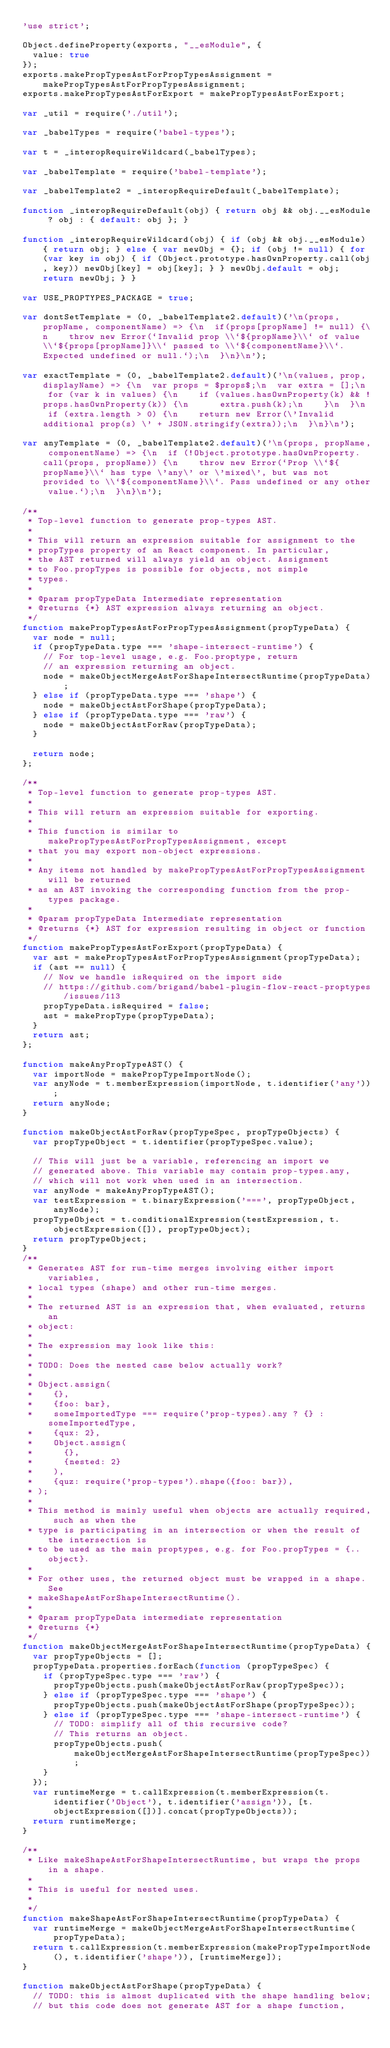<code> <loc_0><loc_0><loc_500><loc_500><_JavaScript_>'use strict';

Object.defineProperty(exports, "__esModule", {
  value: true
});
exports.makePropTypesAstForPropTypesAssignment = makePropTypesAstForPropTypesAssignment;
exports.makePropTypesAstForExport = makePropTypesAstForExport;

var _util = require('./util');

var _babelTypes = require('babel-types');

var t = _interopRequireWildcard(_babelTypes);

var _babelTemplate = require('babel-template');

var _babelTemplate2 = _interopRequireDefault(_babelTemplate);

function _interopRequireDefault(obj) { return obj && obj.__esModule ? obj : { default: obj }; }

function _interopRequireWildcard(obj) { if (obj && obj.__esModule) { return obj; } else { var newObj = {}; if (obj != null) { for (var key in obj) { if (Object.prototype.hasOwnProperty.call(obj, key)) newObj[key] = obj[key]; } } newObj.default = obj; return newObj; } }

var USE_PROPTYPES_PACKAGE = true;

var dontSetTemplate = (0, _babelTemplate2.default)('\n(props, propName, componentName) => {\n  if(props[propName] != null) {\n    throw new Error(`Invalid prop \\`${propName}\\` of value \\`${props[propName]}\\` passed to \\`${componentName}\\`. Expected undefined or null.`);\n  }\n}\n');

var exactTemplate = (0, _babelTemplate2.default)('\n(values, prop, displayName) => {\n  var props = $props$;\n  var extra = [];\n  for (var k in values) {\n    if (values.hasOwnProperty(k) && !props.hasOwnProperty(k)) {\n      extra.push(k);\n    }\n  }\n  if (extra.length > 0) {\n    return new Error(\'Invalid additional prop(s) \' + JSON.stringify(extra));\n  }\n}\n');

var anyTemplate = (0, _babelTemplate2.default)('\n(props, propName, componentName) => {\n  if (!Object.prototype.hasOwnProperty.call(props, propName)) {\n    throw new Error(`Prop \\`${propName}\\` has type \'any\' or \'mixed\', but was not provided to \\`${componentName}\\`. Pass undefined or any other value.`);\n  }\n}\n');

/**
 * Top-level function to generate prop-types AST.
 *
 * This will return an expression suitable for assignment to the
 * propTypes property of an React component. In particular,
 * the AST returned will always yield an object. Assignment
 * to Foo.propTypes is possible for objects, not simple
 * types.
 *
 * @param propTypeData Intermediate representation
 * @returns {*} AST expression always returning an object.
 */
function makePropTypesAstForPropTypesAssignment(propTypeData) {
  var node = null;
  if (propTypeData.type === 'shape-intersect-runtime') {
    // For top-level usage, e.g. Foo.proptype, return
    // an expression returning an object.
    node = makeObjectMergeAstForShapeIntersectRuntime(propTypeData);
  } else if (propTypeData.type === 'shape') {
    node = makeObjectAstForShape(propTypeData);
  } else if (propTypeData.type === 'raw') {
    node = makeObjectAstForRaw(propTypeData);
  }

  return node;
};

/**
 * Top-level function to generate prop-types AST.
 *
 * This will return an expression suitable for exporting.
 *
 * This function is similar to makePropTypesAstForPropTypesAssignment, except
 * that you may export non-object expressions.
 *
 * Any items not handled by makePropTypesAstForPropTypesAssignment will be returned
 * as an AST invoking the corresponding function from the prop-types package.
 *
 * @param propTypeData Intermediate representation
 * @returns {*} AST for expression resulting in object or function
 */
function makePropTypesAstForExport(propTypeData) {
  var ast = makePropTypesAstForPropTypesAssignment(propTypeData);
  if (ast == null) {
    // Now we handle isRequired on the import side
    // https://github.com/brigand/babel-plugin-flow-react-proptypes/issues/113
    propTypeData.isRequired = false;
    ast = makePropType(propTypeData);
  }
  return ast;
};

function makeAnyPropTypeAST() {
  var importNode = makePropTypeImportNode();
  var anyNode = t.memberExpression(importNode, t.identifier('any'));
  return anyNode;
}

function makeObjectAstForRaw(propTypeSpec, propTypeObjects) {
  var propTypeObject = t.identifier(propTypeSpec.value);

  // This will just be a variable, referencing an import we
  // generated above. This variable may contain prop-types.any,
  // which will not work when used in an intersection.
  var anyNode = makeAnyPropTypeAST();
  var testExpression = t.binaryExpression('===', propTypeObject, anyNode);
  propTypeObject = t.conditionalExpression(testExpression, t.objectExpression([]), propTypeObject);
  return propTypeObject;
}
/**
 * Generates AST for run-time merges involving either import variables,
 * local types (shape) and other run-time merges.
 *
 * The returned AST is an expression that, when evaluated, returns an
 * object:
 *
 * The expression may look like this:
 *
 * TODO: Does the nested case below actually work?
 *
 * Object.assign(
 *    {},
 *    {foo: bar},
 *    someImportedType === require('prop-types).any ? {} : someImportedType,
 *    {qux: 2},
 *    Object.assign(
 *      {},
 *      {nested: 2}
 *    ),
 *    {quz: require('prop-types').shape({foo: bar}),
 * );
 *
 * This method is mainly useful when objects are actually required, such as when the
 * type is participating in an intersection or when the result of the intersection is
 * to be used as the main proptypes, e.g. for Foo.propTypes = {..object}.
 *
 * For other uses, the returned object must be wrapped in a shape. See
 * makeShapeAstForShapeIntersectRuntime().
 *
 * @param propTypeData intermediate representation
 * @returns {*}
 */
function makeObjectMergeAstForShapeIntersectRuntime(propTypeData) {
  var propTypeObjects = [];
  propTypeData.properties.forEach(function (propTypeSpec) {
    if (propTypeSpec.type === 'raw') {
      propTypeObjects.push(makeObjectAstForRaw(propTypeSpec));
    } else if (propTypeSpec.type === 'shape') {
      propTypeObjects.push(makeObjectAstForShape(propTypeSpec));
    } else if (propTypeSpec.type === 'shape-intersect-runtime') {
      // TODO: simplify all of this recursive code?
      // This returns an object.
      propTypeObjects.push(makeObjectMergeAstForShapeIntersectRuntime(propTypeSpec));
    }
  });
  var runtimeMerge = t.callExpression(t.memberExpression(t.identifier('Object'), t.identifier('assign')), [t.objectExpression([])].concat(propTypeObjects));
  return runtimeMerge;
}

/**
 * Like makeShapeAstForShapeIntersectRuntime, but wraps the props in a shape.
 *
 * This is useful for nested uses.
 *
 */
function makeShapeAstForShapeIntersectRuntime(propTypeData) {
  var runtimeMerge = makeObjectMergeAstForShapeIntersectRuntime(propTypeData);
  return t.callExpression(t.memberExpression(makePropTypeImportNode(), t.identifier('shape')), [runtimeMerge]);
}

function makeObjectAstForShape(propTypeData) {
  // TODO: this is almost duplicated with the shape handling below;
  // but this code does not generate AST for a shape function,</code> 